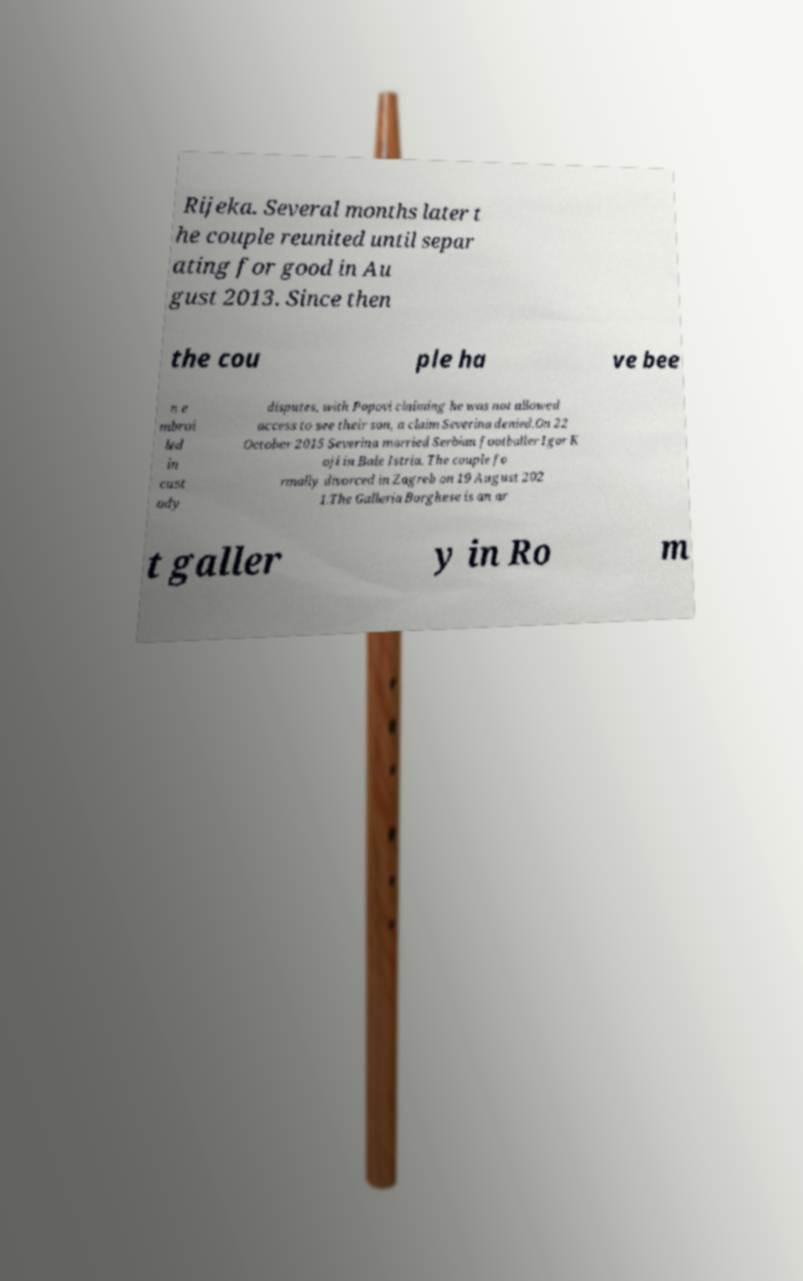Can you accurately transcribe the text from the provided image for me? Rijeka. Several months later t he couple reunited until separ ating for good in Au gust 2013. Since then the cou ple ha ve bee n e mbroi led in cust ody disputes, with Popovi claiming he was not allowed access to see their son, a claim Severina denied.On 22 October 2015 Severina married Serbian footballer Igor K oji in Bale Istria. The couple fo rmally divorced in Zagreb on 19 August 202 1.The Galleria Borghese is an ar t galler y in Ro m 